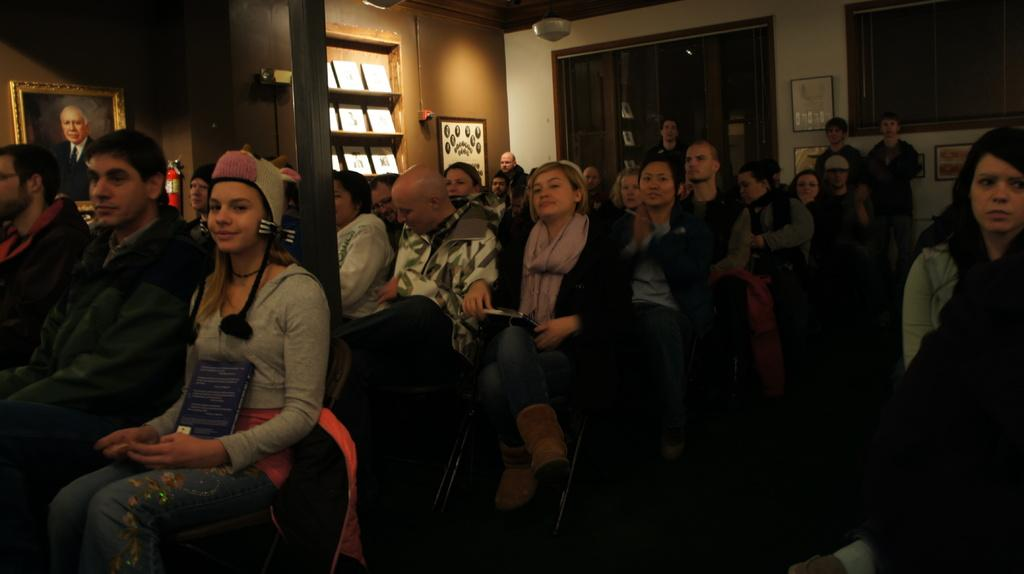What are the people in the image doing? The people in the image are sitting on chairs. What can be seen on the wall in the image? There are photo frames on the wall in the image. What type of songs are the lizards singing in the image? There are no lizards present in the image, so they cannot be singing any songs. 